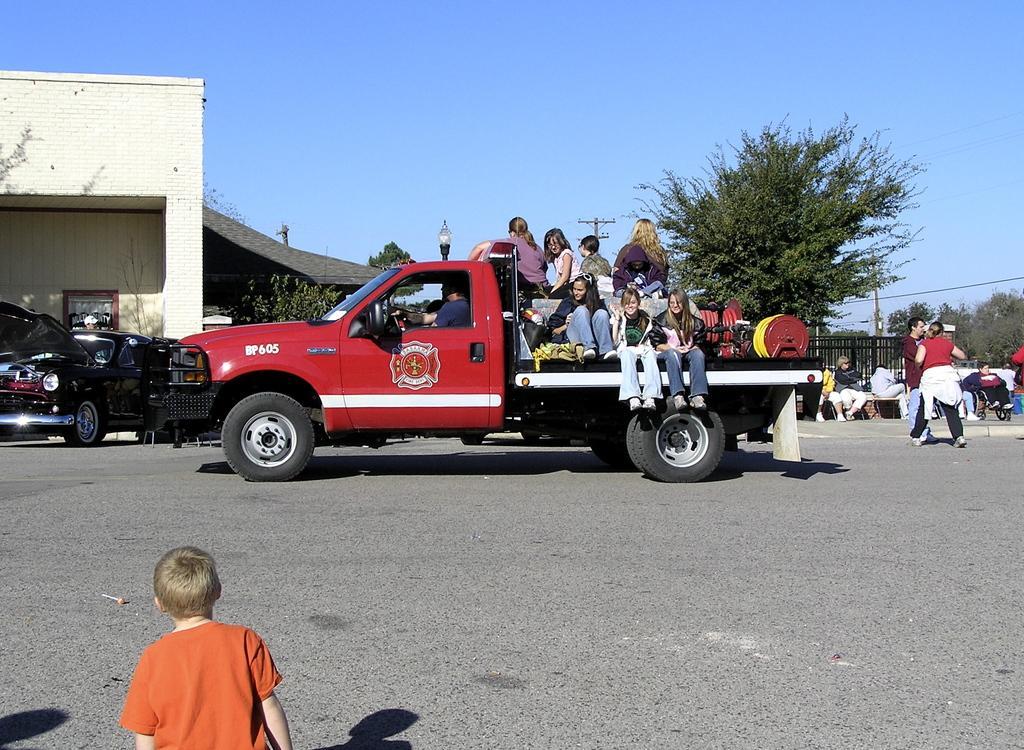In one or two sentences, can you explain what this image depicts? In the picture we can see the child wearing orange color T-shirt is on the road. Here we can see these people are sitting in the vehicle which is on the road, these people are standing on the road. Here we can see other vehicles, trees, current poles, light poles, wires, buildings and sky in the background. 